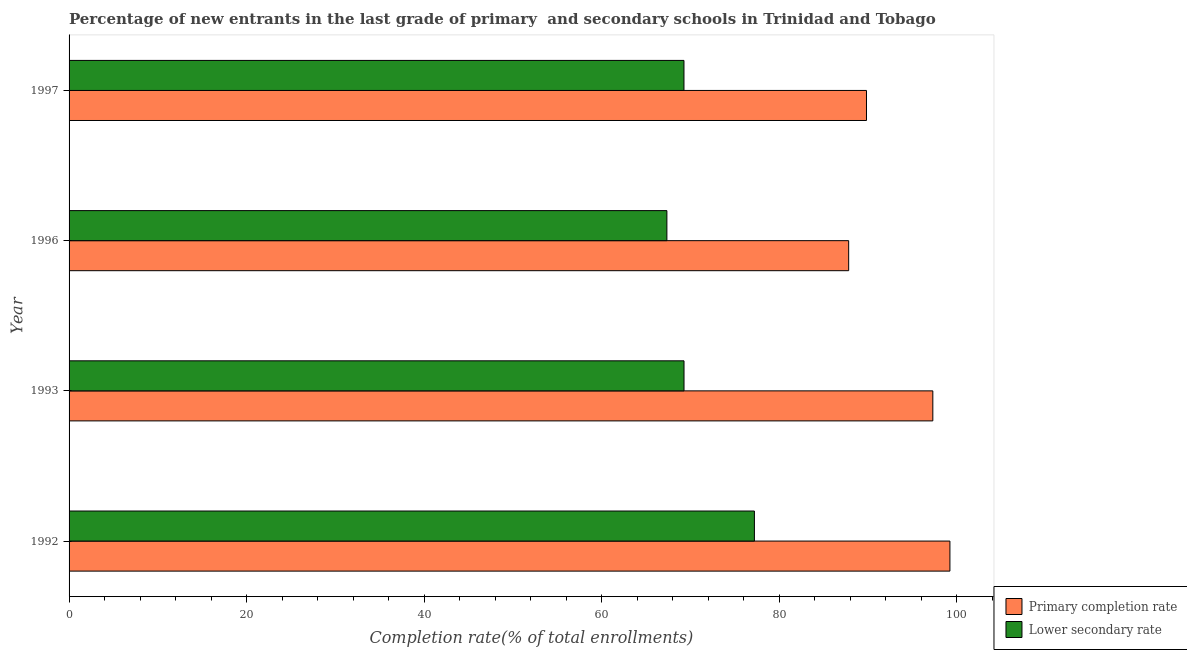How many groups of bars are there?
Give a very brief answer. 4. Are the number of bars per tick equal to the number of legend labels?
Provide a short and direct response. Yes. Are the number of bars on each tick of the Y-axis equal?
Give a very brief answer. Yes. How many bars are there on the 4th tick from the bottom?
Provide a short and direct response. 2. What is the label of the 4th group of bars from the top?
Your answer should be compact. 1992. In how many cases, is the number of bars for a given year not equal to the number of legend labels?
Ensure brevity in your answer.  0. What is the completion rate in secondary schools in 1992?
Provide a succinct answer. 77.2. Across all years, what is the maximum completion rate in secondary schools?
Provide a succinct answer. 77.2. Across all years, what is the minimum completion rate in primary schools?
Provide a short and direct response. 87.81. In which year was the completion rate in secondary schools minimum?
Your answer should be very brief. 1996. What is the total completion rate in primary schools in the graph?
Provide a succinct answer. 374.14. What is the difference between the completion rate in secondary schools in 1993 and that in 1996?
Offer a very short reply. 1.93. What is the difference between the completion rate in primary schools in 1996 and the completion rate in secondary schools in 1993?
Offer a very short reply. 18.55. What is the average completion rate in primary schools per year?
Provide a succinct answer. 93.54. In the year 1993, what is the difference between the completion rate in secondary schools and completion rate in primary schools?
Provide a succinct answer. -28.03. In how many years, is the completion rate in secondary schools greater than 52 %?
Your answer should be compact. 4. What is the ratio of the completion rate in primary schools in 1992 to that in 1997?
Your answer should be very brief. 1.1. Is the completion rate in secondary schools in 1993 less than that in 1997?
Ensure brevity in your answer.  No. What is the difference between the highest and the second highest completion rate in primary schools?
Your answer should be compact. 1.92. What is the difference between the highest and the lowest completion rate in secondary schools?
Ensure brevity in your answer.  9.86. In how many years, is the completion rate in primary schools greater than the average completion rate in primary schools taken over all years?
Give a very brief answer. 2. What does the 1st bar from the top in 1992 represents?
Offer a very short reply. Lower secondary rate. What does the 1st bar from the bottom in 1996 represents?
Offer a terse response. Primary completion rate. Are all the bars in the graph horizontal?
Your answer should be compact. Yes. How many years are there in the graph?
Give a very brief answer. 4. Does the graph contain any zero values?
Your answer should be very brief. No. Where does the legend appear in the graph?
Make the answer very short. Bottom right. How many legend labels are there?
Provide a succinct answer. 2. What is the title of the graph?
Provide a short and direct response. Percentage of new entrants in the last grade of primary  and secondary schools in Trinidad and Tobago. Does "Infant" appear as one of the legend labels in the graph?
Your answer should be compact. No. What is the label or title of the X-axis?
Make the answer very short. Completion rate(% of total enrollments). What is the label or title of the Y-axis?
Your answer should be very brief. Year. What is the Completion rate(% of total enrollments) in Primary completion rate in 1992?
Ensure brevity in your answer.  99.22. What is the Completion rate(% of total enrollments) of Lower secondary rate in 1992?
Ensure brevity in your answer.  77.2. What is the Completion rate(% of total enrollments) of Primary completion rate in 1993?
Offer a terse response. 97.29. What is the Completion rate(% of total enrollments) of Lower secondary rate in 1993?
Keep it short and to the point. 69.27. What is the Completion rate(% of total enrollments) of Primary completion rate in 1996?
Keep it short and to the point. 87.81. What is the Completion rate(% of total enrollments) of Lower secondary rate in 1996?
Keep it short and to the point. 67.34. What is the Completion rate(% of total enrollments) in Primary completion rate in 1997?
Give a very brief answer. 89.82. What is the Completion rate(% of total enrollments) in Lower secondary rate in 1997?
Make the answer very short. 69.26. Across all years, what is the maximum Completion rate(% of total enrollments) in Primary completion rate?
Your response must be concise. 99.22. Across all years, what is the maximum Completion rate(% of total enrollments) of Lower secondary rate?
Your answer should be compact. 77.2. Across all years, what is the minimum Completion rate(% of total enrollments) of Primary completion rate?
Keep it short and to the point. 87.81. Across all years, what is the minimum Completion rate(% of total enrollments) in Lower secondary rate?
Your answer should be very brief. 67.34. What is the total Completion rate(% of total enrollments) in Primary completion rate in the graph?
Your answer should be compact. 374.14. What is the total Completion rate(% of total enrollments) in Lower secondary rate in the graph?
Ensure brevity in your answer.  283.06. What is the difference between the Completion rate(% of total enrollments) in Primary completion rate in 1992 and that in 1993?
Your answer should be very brief. 1.92. What is the difference between the Completion rate(% of total enrollments) of Lower secondary rate in 1992 and that in 1993?
Ensure brevity in your answer.  7.93. What is the difference between the Completion rate(% of total enrollments) in Primary completion rate in 1992 and that in 1996?
Keep it short and to the point. 11.4. What is the difference between the Completion rate(% of total enrollments) in Lower secondary rate in 1992 and that in 1996?
Your answer should be very brief. 9.86. What is the difference between the Completion rate(% of total enrollments) of Primary completion rate in 1992 and that in 1997?
Give a very brief answer. 9.4. What is the difference between the Completion rate(% of total enrollments) of Lower secondary rate in 1992 and that in 1997?
Make the answer very short. 7.93. What is the difference between the Completion rate(% of total enrollments) in Primary completion rate in 1993 and that in 1996?
Your answer should be very brief. 9.48. What is the difference between the Completion rate(% of total enrollments) in Lower secondary rate in 1993 and that in 1996?
Provide a short and direct response. 1.93. What is the difference between the Completion rate(% of total enrollments) in Primary completion rate in 1993 and that in 1997?
Make the answer very short. 7.47. What is the difference between the Completion rate(% of total enrollments) of Lower secondary rate in 1993 and that in 1997?
Give a very brief answer. 0.01. What is the difference between the Completion rate(% of total enrollments) of Primary completion rate in 1996 and that in 1997?
Offer a terse response. -2.01. What is the difference between the Completion rate(% of total enrollments) in Lower secondary rate in 1996 and that in 1997?
Offer a very short reply. -1.92. What is the difference between the Completion rate(% of total enrollments) of Primary completion rate in 1992 and the Completion rate(% of total enrollments) of Lower secondary rate in 1993?
Your answer should be compact. 29.95. What is the difference between the Completion rate(% of total enrollments) in Primary completion rate in 1992 and the Completion rate(% of total enrollments) in Lower secondary rate in 1996?
Your answer should be compact. 31.88. What is the difference between the Completion rate(% of total enrollments) of Primary completion rate in 1992 and the Completion rate(% of total enrollments) of Lower secondary rate in 1997?
Offer a very short reply. 29.96. What is the difference between the Completion rate(% of total enrollments) of Primary completion rate in 1993 and the Completion rate(% of total enrollments) of Lower secondary rate in 1996?
Offer a terse response. 29.95. What is the difference between the Completion rate(% of total enrollments) of Primary completion rate in 1993 and the Completion rate(% of total enrollments) of Lower secondary rate in 1997?
Your response must be concise. 28.03. What is the difference between the Completion rate(% of total enrollments) in Primary completion rate in 1996 and the Completion rate(% of total enrollments) in Lower secondary rate in 1997?
Provide a succinct answer. 18.55. What is the average Completion rate(% of total enrollments) of Primary completion rate per year?
Keep it short and to the point. 93.54. What is the average Completion rate(% of total enrollments) of Lower secondary rate per year?
Offer a very short reply. 70.77. In the year 1992, what is the difference between the Completion rate(% of total enrollments) in Primary completion rate and Completion rate(% of total enrollments) in Lower secondary rate?
Offer a very short reply. 22.02. In the year 1993, what is the difference between the Completion rate(% of total enrollments) of Primary completion rate and Completion rate(% of total enrollments) of Lower secondary rate?
Your response must be concise. 28.03. In the year 1996, what is the difference between the Completion rate(% of total enrollments) of Primary completion rate and Completion rate(% of total enrollments) of Lower secondary rate?
Offer a terse response. 20.47. In the year 1997, what is the difference between the Completion rate(% of total enrollments) of Primary completion rate and Completion rate(% of total enrollments) of Lower secondary rate?
Provide a short and direct response. 20.56. What is the ratio of the Completion rate(% of total enrollments) in Primary completion rate in 1992 to that in 1993?
Keep it short and to the point. 1.02. What is the ratio of the Completion rate(% of total enrollments) in Lower secondary rate in 1992 to that in 1993?
Ensure brevity in your answer.  1.11. What is the ratio of the Completion rate(% of total enrollments) in Primary completion rate in 1992 to that in 1996?
Give a very brief answer. 1.13. What is the ratio of the Completion rate(% of total enrollments) of Lower secondary rate in 1992 to that in 1996?
Make the answer very short. 1.15. What is the ratio of the Completion rate(% of total enrollments) in Primary completion rate in 1992 to that in 1997?
Your answer should be very brief. 1.1. What is the ratio of the Completion rate(% of total enrollments) of Lower secondary rate in 1992 to that in 1997?
Your response must be concise. 1.11. What is the ratio of the Completion rate(% of total enrollments) in Primary completion rate in 1993 to that in 1996?
Your response must be concise. 1.11. What is the ratio of the Completion rate(% of total enrollments) of Lower secondary rate in 1993 to that in 1996?
Make the answer very short. 1.03. What is the ratio of the Completion rate(% of total enrollments) in Primary completion rate in 1993 to that in 1997?
Provide a succinct answer. 1.08. What is the ratio of the Completion rate(% of total enrollments) of Primary completion rate in 1996 to that in 1997?
Make the answer very short. 0.98. What is the ratio of the Completion rate(% of total enrollments) of Lower secondary rate in 1996 to that in 1997?
Your answer should be compact. 0.97. What is the difference between the highest and the second highest Completion rate(% of total enrollments) in Primary completion rate?
Offer a very short reply. 1.92. What is the difference between the highest and the second highest Completion rate(% of total enrollments) of Lower secondary rate?
Ensure brevity in your answer.  7.93. What is the difference between the highest and the lowest Completion rate(% of total enrollments) of Primary completion rate?
Your answer should be compact. 11.4. What is the difference between the highest and the lowest Completion rate(% of total enrollments) in Lower secondary rate?
Keep it short and to the point. 9.86. 